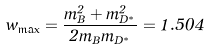<formula> <loc_0><loc_0><loc_500><loc_500>w _ { \max } = \frac { m _ { B } ^ { 2 } + m _ { D ^ { * } } ^ { 2 } } { 2 m _ { B } m _ { D ^ { * } } } = 1 . 5 0 4</formula> 